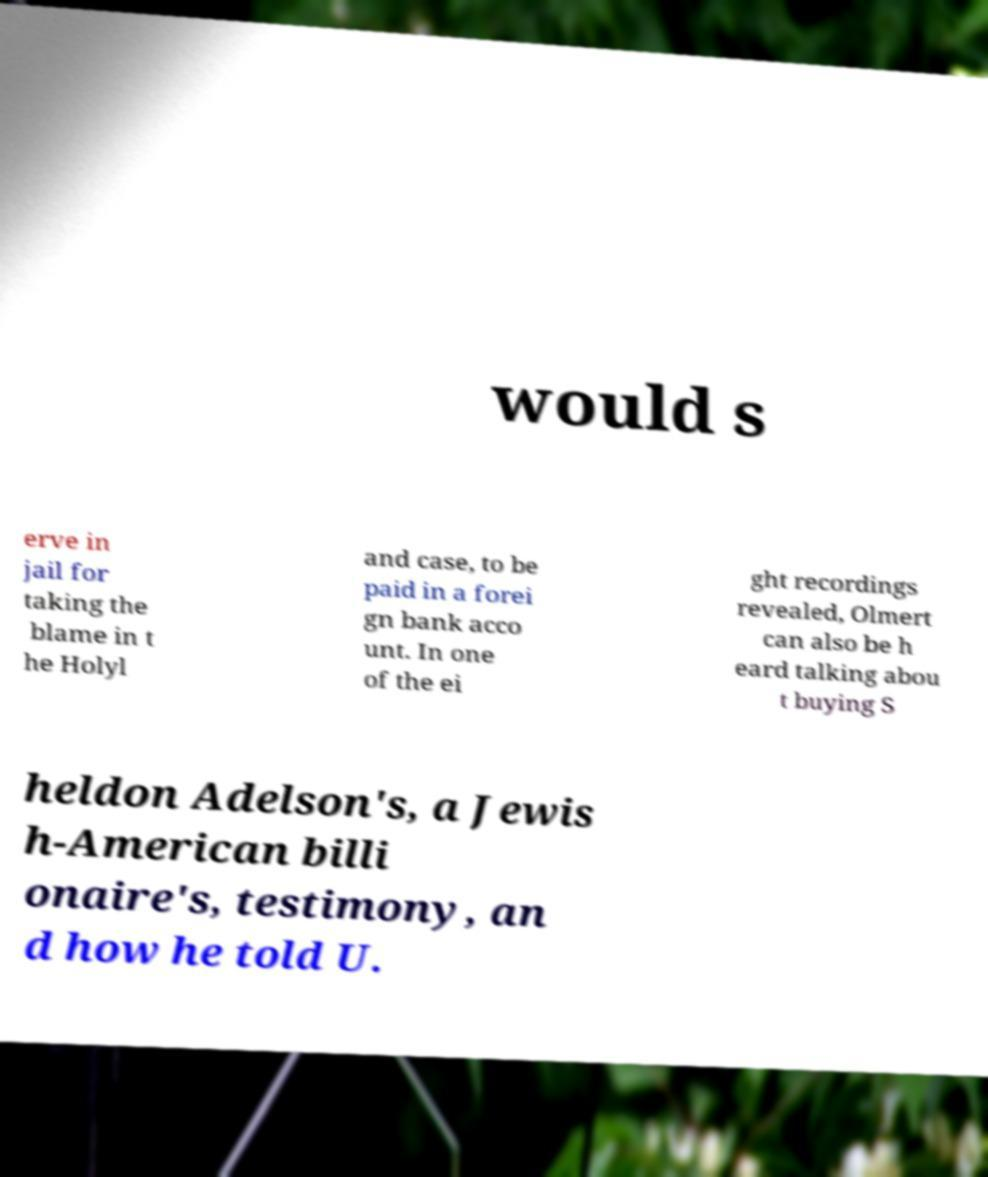There's text embedded in this image that I need extracted. Can you transcribe it verbatim? would s erve in jail for taking the blame in t he Holyl and case, to be paid in a forei gn bank acco unt. In one of the ei ght recordings revealed, Olmert can also be h eard talking abou t buying S heldon Adelson's, a Jewis h-American billi onaire's, testimony, an d how he told U. 